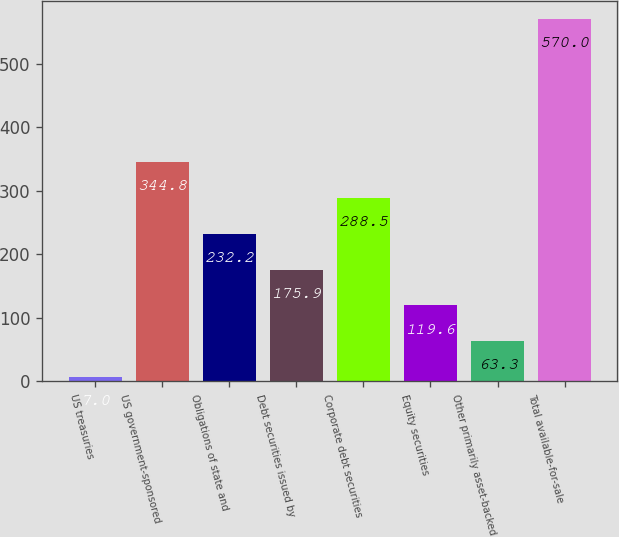<chart> <loc_0><loc_0><loc_500><loc_500><bar_chart><fcel>US treasuries<fcel>US government-sponsored<fcel>Obligations of state and<fcel>Debt securities issued by<fcel>Corporate debt securities<fcel>Equity securities<fcel>Other primarily asset-backed<fcel>Total available-for-sale<nl><fcel>7<fcel>344.8<fcel>232.2<fcel>175.9<fcel>288.5<fcel>119.6<fcel>63.3<fcel>570<nl></chart> 